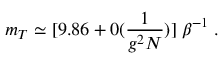Convert formula to latex. <formula><loc_0><loc_0><loc_500><loc_500>m _ { T } \simeq [ 9 . 8 6 + 0 ( \frac { 1 } { g ^ { 2 } N } ) ] \, \beta ^ { - 1 } \, .</formula> 